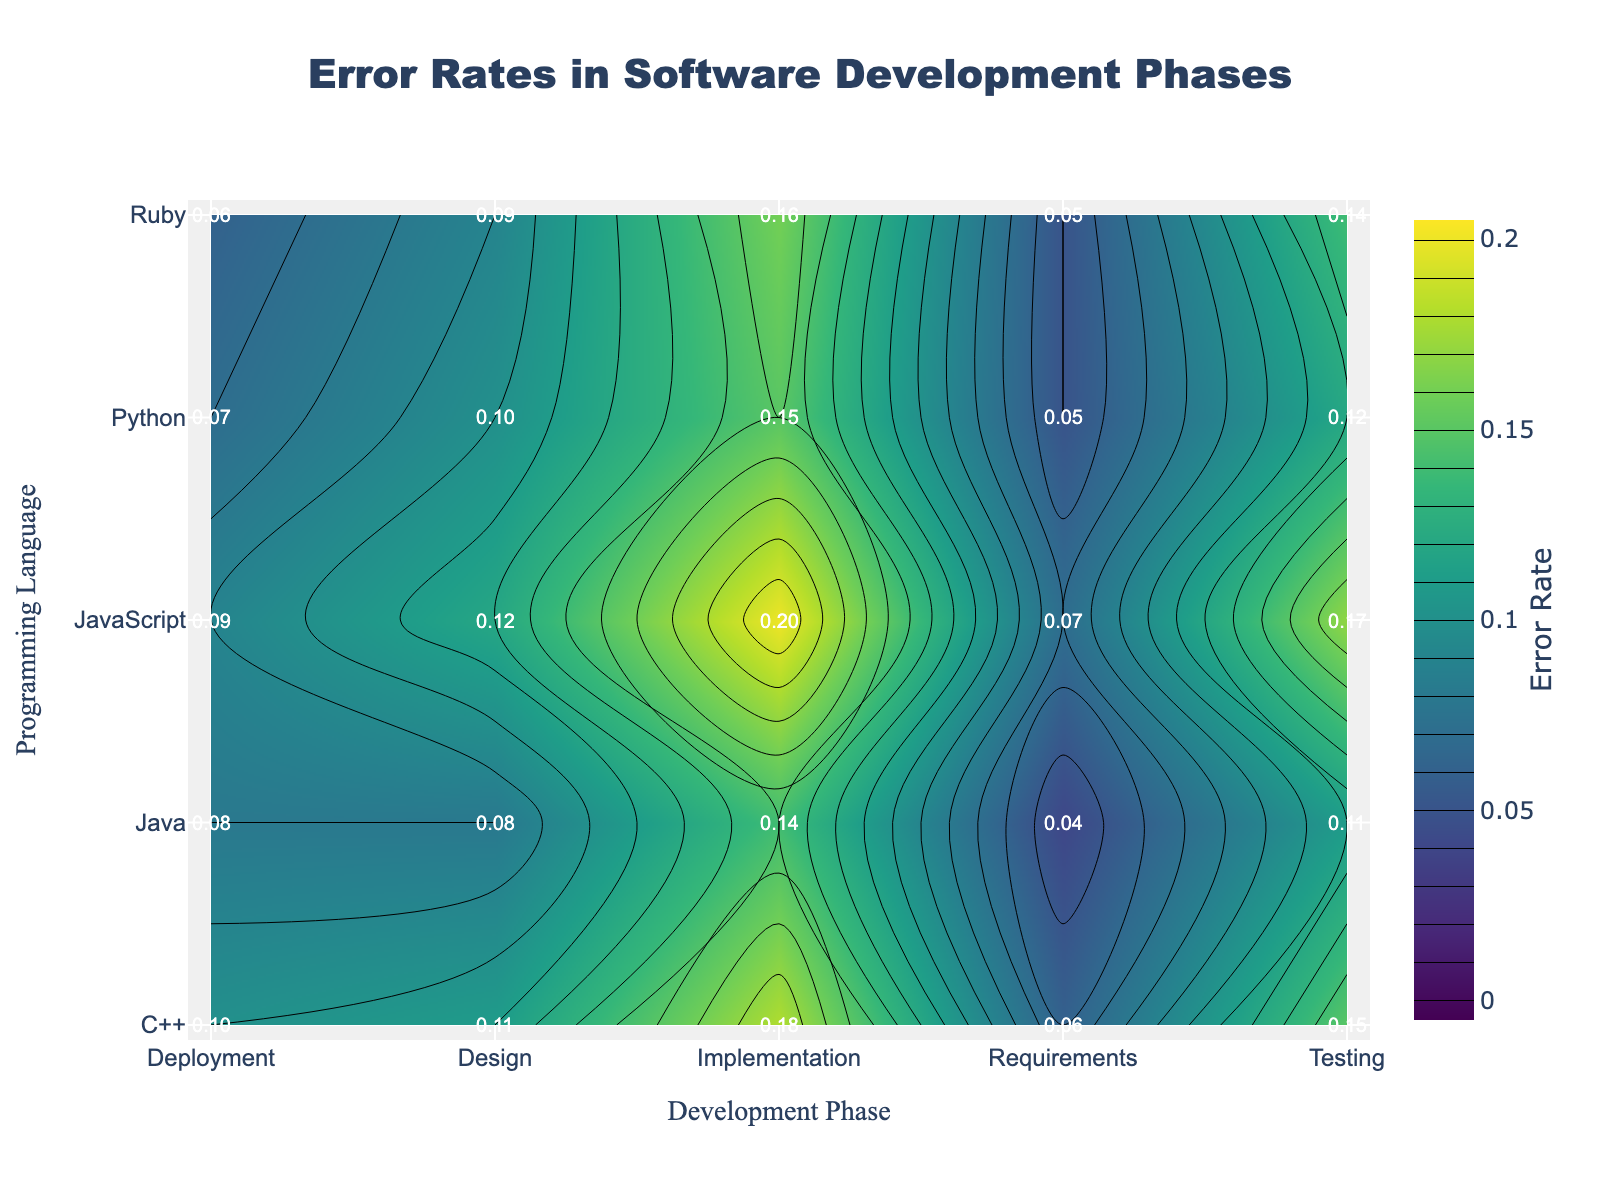What is the error rate for Python in the Implementation phase? Look under the column 'Implementation' and the row 'Python' in the figure. The value is shown as 0.15
Answer: 0.15 Which programming language has the highest error rate in the Testing phase? Look under the column 'Testing' and compare the values for each programming language. The highest value is 0.17 for JavaScript
Answer: JavaScript What is the average error rate across all phases for Java? Sum all error rates for Java (0.04 + 0.08 + 0.14 + 0.11 + 0.08) and divide by 5: (0.04 + 0.08 + 0.14 + 0.11 + 0.08) / 5 = 0.09
Answer: 0.09 Which phase has the lowest average error rate across all programming languages? Calculate the average error rate for each phase by summing specific phase values and dividing by the number of programming languages:
  - Requirements: (0.05 + 0.04 + 0.06 + 0.07 + 0.05) / 5 = 0.054
  - Design: (0.10 + 0.08 + 0.11 + 0.12 + 0.09) / 5 = 0.10
  - Implementation: (0.15 + 0.14 + 0.18 + 0.20 + 0.16) / 5 = 0.166
  - Testing: (0.12 + 0.11 + 0.15 + 0.17 + 0.14) / 5 = 0.138
  - Deployment: (0.07 + 0.08 + 0.10 + 0.09 + 0.06) / 5 = 0.08
  The lowest average error rate is for Requirements (0.054)
Answer: Requirements How much higher is the error rate for JavaScript in Implementation compared to Ruby in the same phase? Subtract Ruby's error rate in the Implementation phase from JavaScript's: 0.20 - 0.16 = 0.04
Answer: 0.04 Which programming language has the lowest error rate overall and in which phase does it occur? Identify lowest error rate value from all data points in the figure. The lowest value is 0.04 in the Requirements phase for Java
Answer: Java, Requirements What is the total error rate for Python across all phases? Sum all the error rates for Python: 0.05 + 0.10 + 0.15 + 0.12 + 0.07 = 0.49
Answer: 0.49 In which phase does C++ have its highest error rate, and what is the value? Check the row for C++ and note down the highest value in the corresponding column. The highest value is in the Implementation phase: 0.18
Answer: Implementation, 0.18 